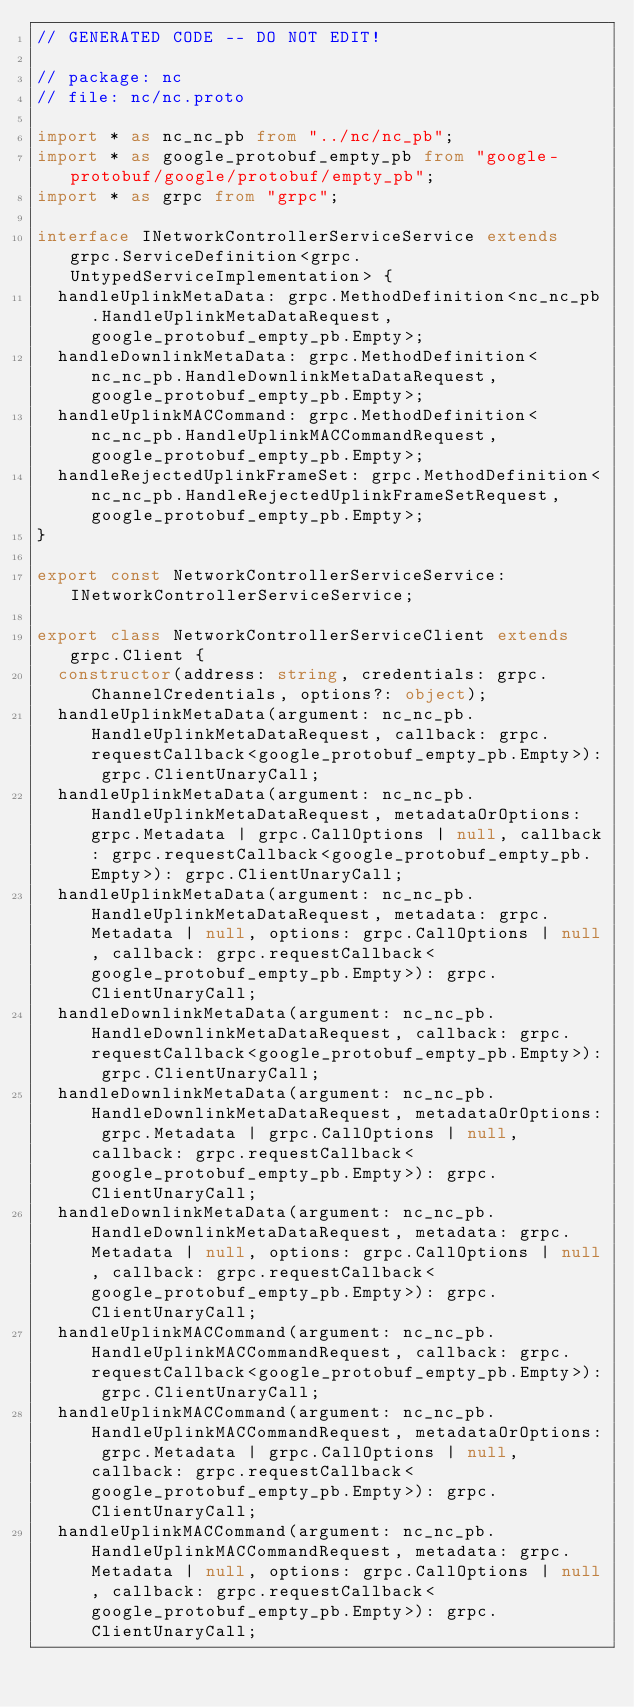<code> <loc_0><loc_0><loc_500><loc_500><_TypeScript_>// GENERATED CODE -- DO NOT EDIT!

// package: nc
// file: nc/nc.proto

import * as nc_nc_pb from "../nc/nc_pb";
import * as google_protobuf_empty_pb from "google-protobuf/google/protobuf/empty_pb";
import * as grpc from "grpc";

interface INetworkControllerServiceService extends grpc.ServiceDefinition<grpc.UntypedServiceImplementation> {
  handleUplinkMetaData: grpc.MethodDefinition<nc_nc_pb.HandleUplinkMetaDataRequest, google_protobuf_empty_pb.Empty>;
  handleDownlinkMetaData: grpc.MethodDefinition<nc_nc_pb.HandleDownlinkMetaDataRequest, google_protobuf_empty_pb.Empty>;
  handleUplinkMACCommand: grpc.MethodDefinition<nc_nc_pb.HandleUplinkMACCommandRequest, google_protobuf_empty_pb.Empty>;
  handleRejectedUplinkFrameSet: grpc.MethodDefinition<nc_nc_pb.HandleRejectedUplinkFrameSetRequest, google_protobuf_empty_pb.Empty>;
}

export const NetworkControllerServiceService: INetworkControllerServiceService;

export class NetworkControllerServiceClient extends grpc.Client {
  constructor(address: string, credentials: grpc.ChannelCredentials, options?: object);
  handleUplinkMetaData(argument: nc_nc_pb.HandleUplinkMetaDataRequest, callback: grpc.requestCallback<google_protobuf_empty_pb.Empty>): grpc.ClientUnaryCall;
  handleUplinkMetaData(argument: nc_nc_pb.HandleUplinkMetaDataRequest, metadataOrOptions: grpc.Metadata | grpc.CallOptions | null, callback: grpc.requestCallback<google_protobuf_empty_pb.Empty>): grpc.ClientUnaryCall;
  handleUplinkMetaData(argument: nc_nc_pb.HandleUplinkMetaDataRequest, metadata: grpc.Metadata | null, options: grpc.CallOptions | null, callback: grpc.requestCallback<google_protobuf_empty_pb.Empty>): grpc.ClientUnaryCall;
  handleDownlinkMetaData(argument: nc_nc_pb.HandleDownlinkMetaDataRequest, callback: grpc.requestCallback<google_protobuf_empty_pb.Empty>): grpc.ClientUnaryCall;
  handleDownlinkMetaData(argument: nc_nc_pb.HandleDownlinkMetaDataRequest, metadataOrOptions: grpc.Metadata | grpc.CallOptions | null, callback: grpc.requestCallback<google_protobuf_empty_pb.Empty>): grpc.ClientUnaryCall;
  handleDownlinkMetaData(argument: nc_nc_pb.HandleDownlinkMetaDataRequest, metadata: grpc.Metadata | null, options: grpc.CallOptions | null, callback: grpc.requestCallback<google_protobuf_empty_pb.Empty>): grpc.ClientUnaryCall;
  handleUplinkMACCommand(argument: nc_nc_pb.HandleUplinkMACCommandRequest, callback: grpc.requestCallback<google_protobuf_empty_pb.Empty>): grpc.ClientUnaryCall;
  handleUplinkMACCommand(argument: nc_nc_pb.HandleUplinkMACCommandRequest, metadataOrOptions: grpc.Metadata | grpc.CallOptions | null, callback: grpc.requestCallback<google_protobuf_empty_pb.Empty>): grpc.ClientUnaryCall;
  handleUplinkMACCommand(argument: nc_nc_pb.HandleUplinkMACCommandRequest, metadata: grpc.Metadata | null, options: grpc.CallOptions | null, callback: grpc.requestCallback<google_protobuf_empty_pb.Empty>): grpc.ClientUnaryCall;</code> 